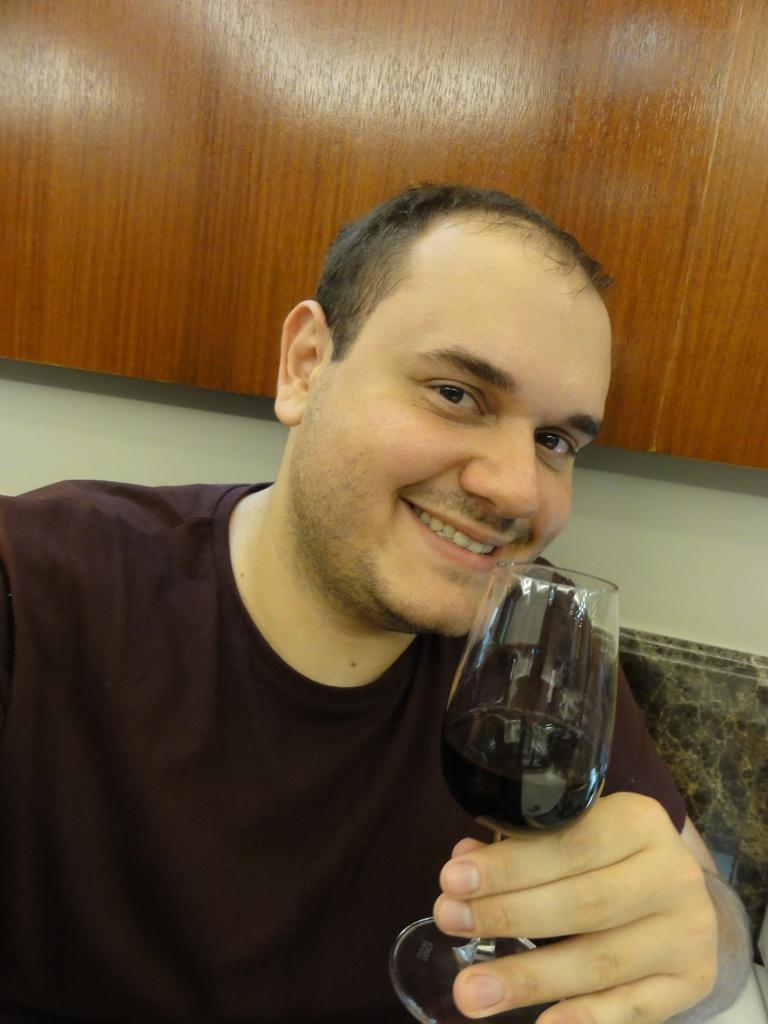Who is present in the image? There is a man in the image. What is the man doing in the image? The man is smiling in the image. What object is the man holding in the image? The man is holding a wine glass in the image. What can be seen in the background of the image? There is a wooden wall in the background of the image. What verse is the man reciting in the image? There is no indication in the image that the man is reciting a verse, so it cannot be determined from the picture. 